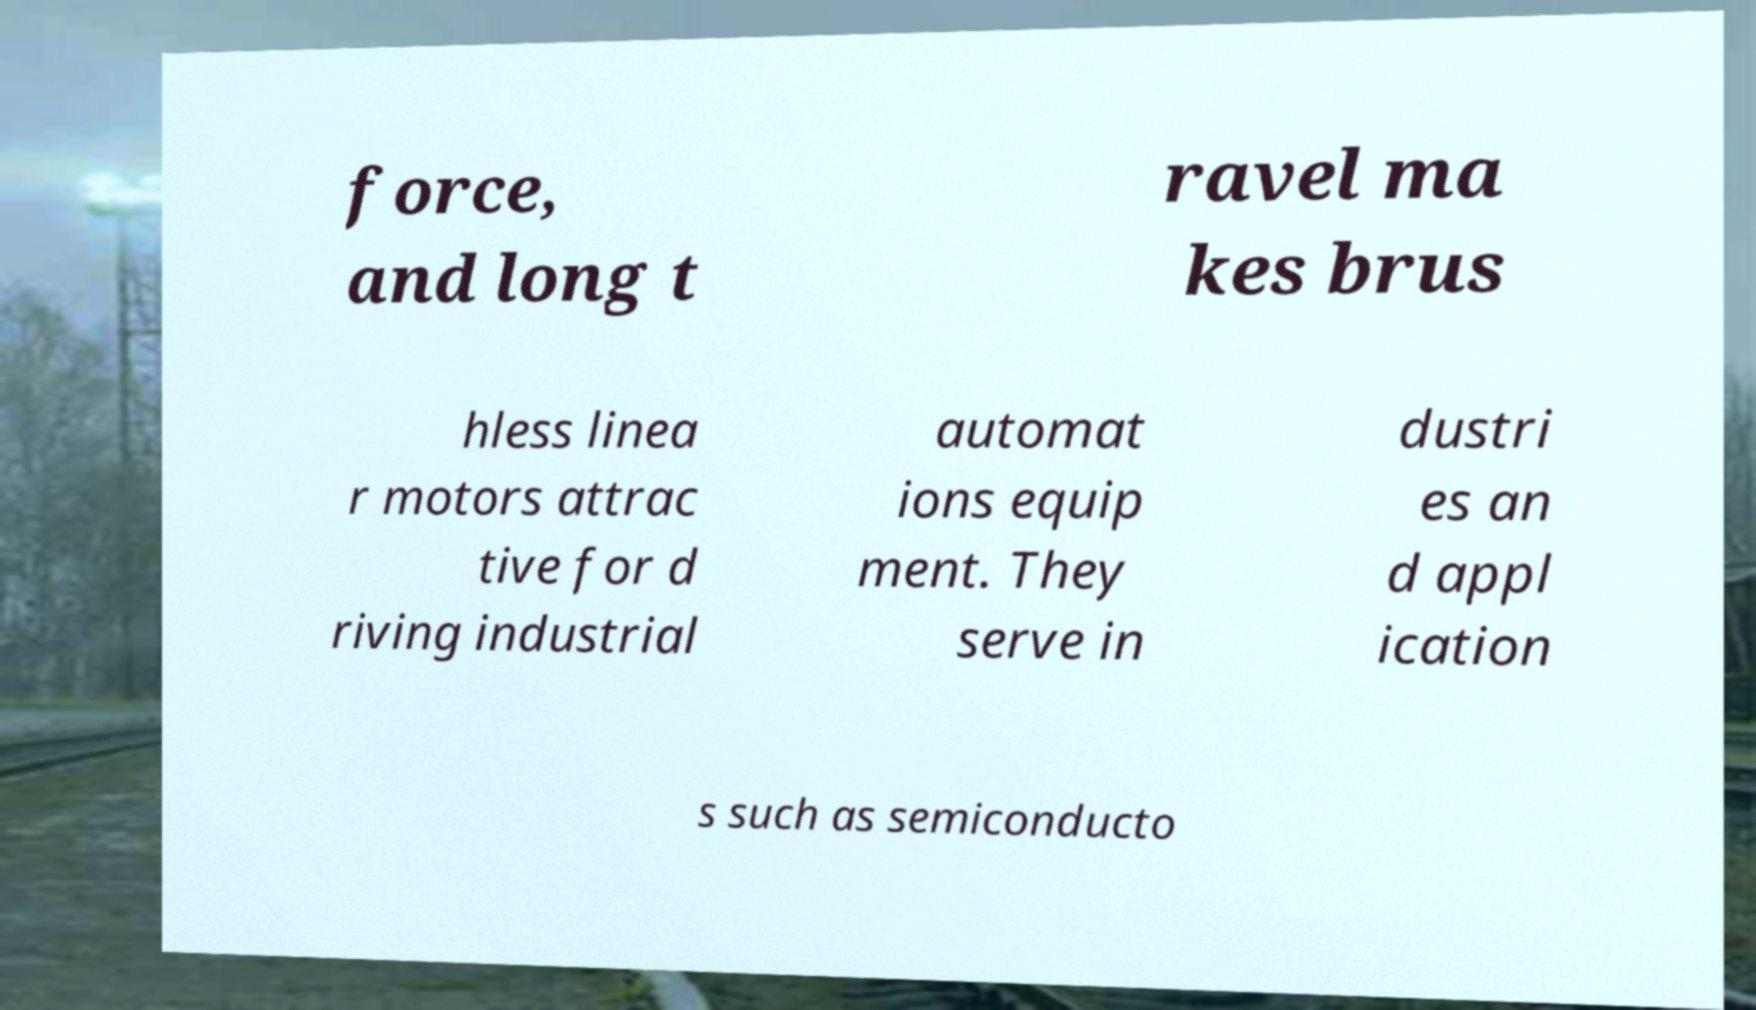I need the written content from this picture converted into text. Can you do that? force, and long t ravel ma kes brus hless linea r motors attrac tive for d riving industrial automat ions equip ment. They serve in dustri es an d appl ication s such as semiconducto 